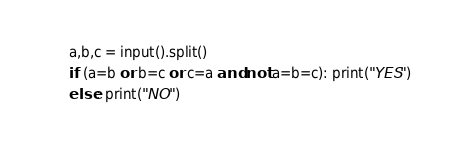<code> <loc_0><loc_0><loc_500><loc_500><_Python_>a,b,c = input().split()
if (a=b or b=c or c=a and not a=b=c): print("YES")
else: print("NO")</code> 